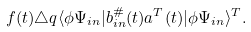<formula> <loc_0><loc_0><loc_500><loc_500>f ( t ) \triangle q \langle \phi \Psi _ { i n } | b _ { i n } ^ { \# } ( t ) a ^ { T } ( t ) | \phi \Psi _ { i n } \rangle ^ { T } .</formula> 